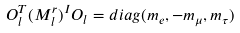<formula> <loc_0><loc_0><loc_500><loc_500>O _ { l } ^ { T } ( M _ { l } ^ { r } ) ^ { I } O _ { l } = d i a g ( m _ { e } , - m _ { \mu } , m _ { \tau } )</formula> 